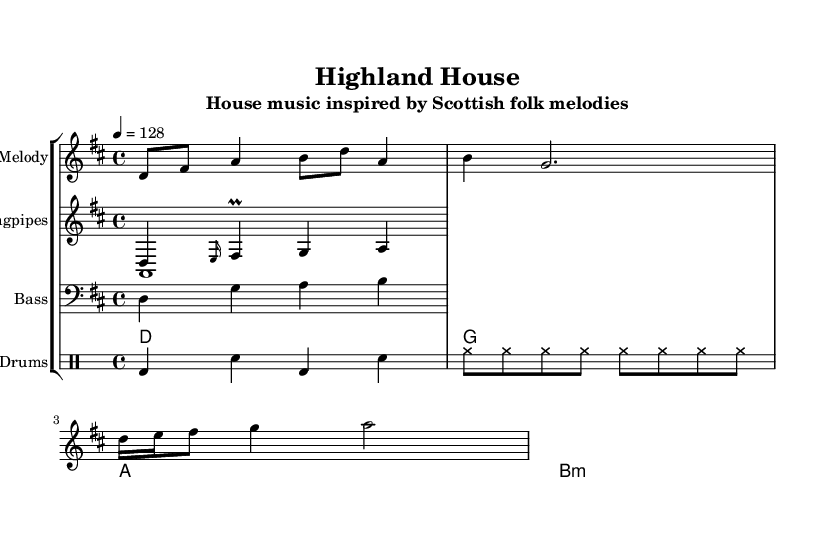What is the key signature of this music? The key signature is D major, which has two sharps (F# and C#). You can identify the key signature by looking at the beginning of the staff where the sharps are indicated. The presence of two sharps confirms that the key is D major.
Answer: D major What is the time signature of this music? The time signature is 4/4, which indicates that there are four beats in each measure and the quarter note receives one beat. You can find the time signature at the beginning of the staff, indicated as 4/4.
Answer: 4/4 What is the tempo marking for this piece? The tempo marking is 128 beats per minute, indicated by the text "4 = 128" above the staff. This means that a quarter note is played at a speed of 128 beats in one minute, establishing the pace for the music.
Answer: 128 Which instrument plays the melody in this music? The melody is played on the staff labeled "Melody." This staff is specifically designated for the melodic line, which is typically where you'll find the primary musical theme.
Answer: Melody How many voices are present in the bagpipes part? There are two voices in the bagpipes part. This is clear from the notation as it shows one voice for the melodic line and another voice, which serves as a drone (sustained sound). The presence of both voices allows for harmonic complexity typical of folk traditions.
Answer: Two What type of rhythm pattern is used in the drums section? The rhythm pattern in the drums section consists of a pattern where the bass drum and snare alternate with eighth notes from the hi-hat. This creates a driving rhythm typical of house music, supporting the overall groove of the piece.
Answer: Alternating bass and snare 